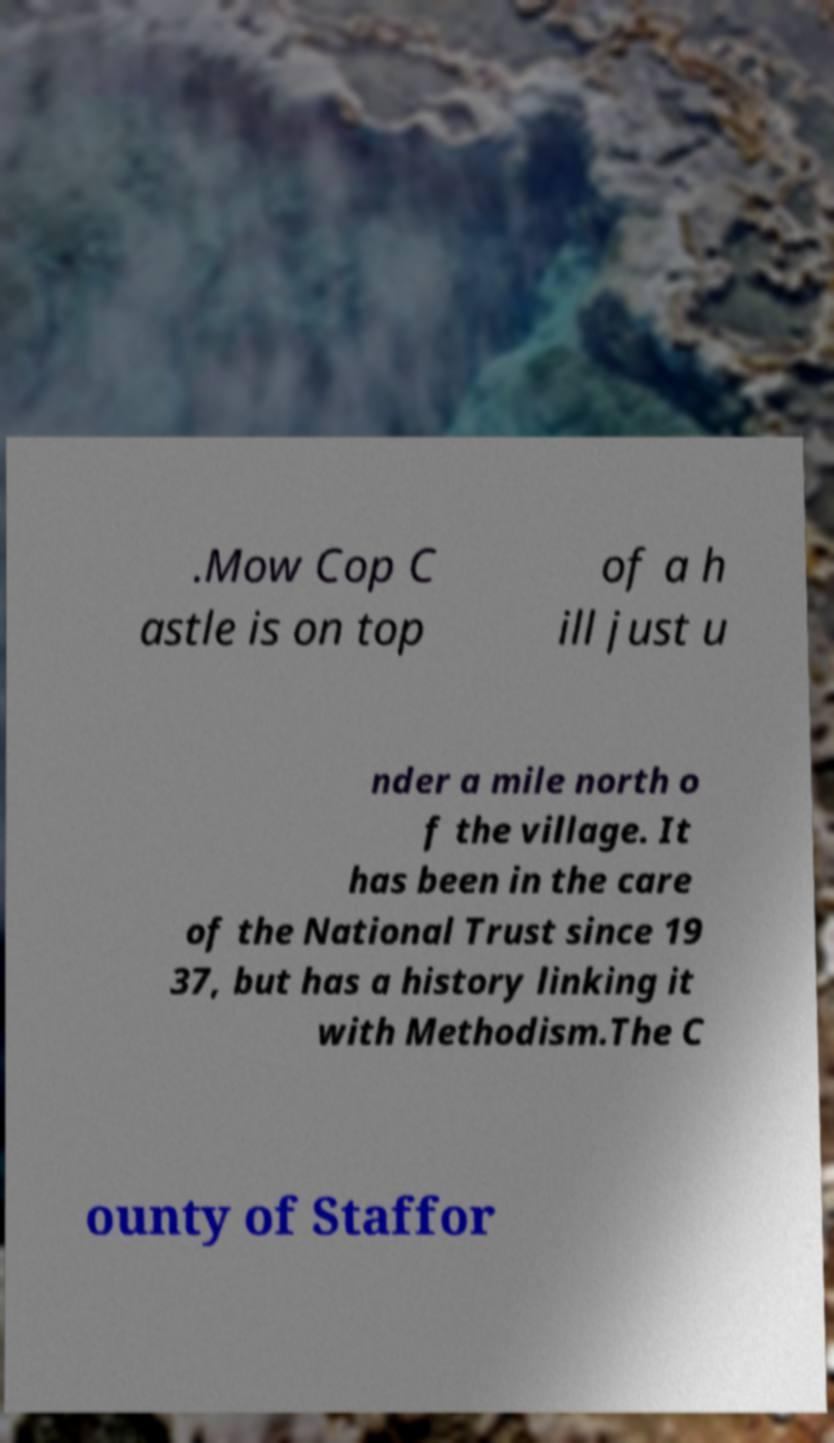Please identify and transcribe the text found in this image. .Mow Cop C astle is on top of a h ill just u nder a mile north o f the village. It has been in the care of the National Trust since 19 37, but has a history linking it with Methodism.The C ounty of Staffor 